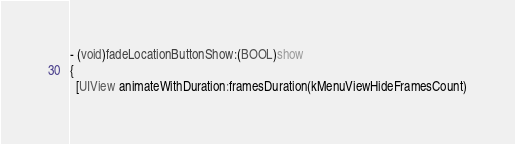Convert code to text. <code><loc_0><loc_0><loc_500><loc_500><_ObjectiveC_>
- (void)fadeLocationButtonShow:(BOOL)show
{
  [UIView animateWithDuration:framesDuration(kMenuViewHideFramesCount)</code> 